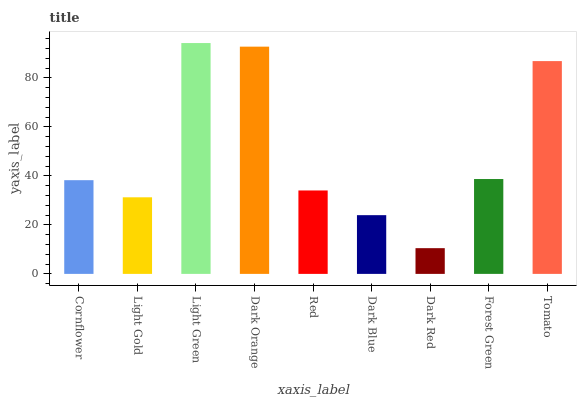Is Dark Red the minimum?
Answer yes or no. Yes. Is Light Green the maximum?
Answer yes or no. Yes. Is Light Gold the minimum?
Answer yes or no. No. Is Light Gold the maximum?
Answer yes or no. No. Is Cornflower greater than Light Gold?
Answer yes or no. Yes. Is Light Gold less than Cornflower?
Answer yes or no. Yes. Is Light Gold greater than Cornflower?
Answer yes or no. No. Is Cornflower less than Light Gold?
Answer yes or no. No. Is Cornflower the high median?
Answer yes or no. Yes. Is Cornflower the low median?
Answer yes or no. Yes. Is Red the high median?
Answer yes or no. No. Is Dark Red the low median?
Answer yes or no. No. 